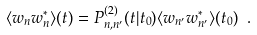Convert formula to latex. <formula><loc_0><loc_0><loc_500><loc_500>\langle w _ { n } w ^ { * } _ { n } \rangle ( t ) = P ^ { ( 2 ) } _ { n , n ^ { \prime } } ( t | t _ { 0 } ) \langle w _ { n ^ { \prime } } w ^ { * } _ { n ^ { \prime } } \rangle ( t _ { 0 } ) \ .</formula> 